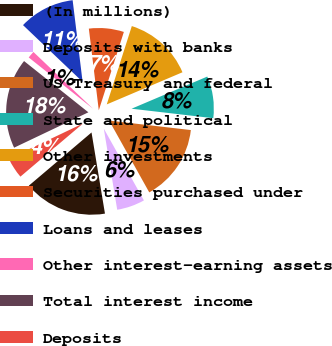Convert chart to OTSL. <chart><loc_0><loc_0><loc_500><loc_500><pie_chart><fcel>(In millions)<fcel>Deposits with banks<fcel>US Treasury and federal<fcel>State and political<fcel>Other investments<fcel>Securities purchased under<fcel>Loans and leases<fcel>Other interest-earning assets<fcel>Total interest income<fcel>Deposits<nl><fcel>16.41%<fcel>5.5%<fcel>15.05%<fcel>8.23%<fcel>13.68%<fcel>6.86%<fcel>10.96%<fcel>1.4%<fcel>17.78%<fcel>4.13%<nl></chart> 